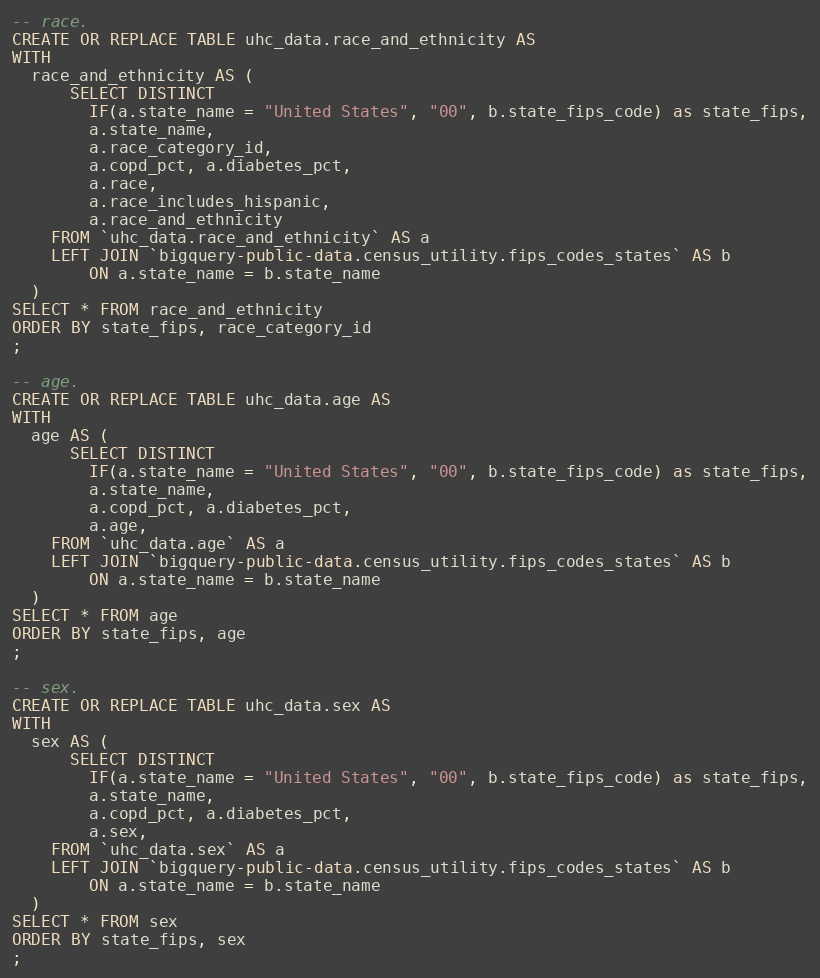<code> <loc_0><loc_0><loc_500><loc_500><_SQL_>-- race.
CREATE OR REPLACE TABLE uhc_data.race_and_ethnicity AS
WITH
  race_and_ethnicity AS (
      SELECT DISTINCT
        IF(a.state_name = "United States", "00", b.state_fips_code) as state_fips,
        a.state_name,
        a.race_category_id,
        a.copd_pct, a.diabetes_pct,
        a.race,
        a.race_includes_hispanic,
        a.race_and_ethnicity
    FROM `uhc_data.race_and_ethnicity` AS a
    LEFT JOIN `bigquery-public-data.census_utility.fips_codes_states` AS b
        ON a.state_name = b.state_name
  )
SELECT * FROM race_and_ethnicity
ORDER BY state_fips, race_category_id
;

-- age.
CREATE OR REPLACE TABLE uhc_data.age AS
WITH
  age AS (
      SELECT DISTINCT
        IF(a.state_name = "United States", "00", b.state_fips_code) as state_fips,
        a.state_name,
        a.copd_pct, a.diabetes_pct,
        a.age,
    FROM `uhc_data.age` AS a
    LEFT JOIN `bigquery-public-data.census_utility.fips_codes_states` AS b
        ON a.state_name = b.state_name
  )
SELECT * FROM age
ORDER BY state_fips, age
;

-- sex.
CREATE OR REPLACE TABLE uhc_data.sex AS
WITH
  sex AS (
      SELECT DISTINCT
        IF(a.state_name = "United States", "00", b.state_fips_code) as state_fips,
        a.state_name,
        a.copd_pct, a.diabetes_pct,
        a.sex,
    FROM `uhc_data.sex` AS a
    LEFT JOIN `bigquery-public-data.census_utility.fips_codes_states` AS b
        ON a.state_name = b.state_name
  )
SELECT * FROM sex
ORDER BY state_fips, sex
;
</code> 